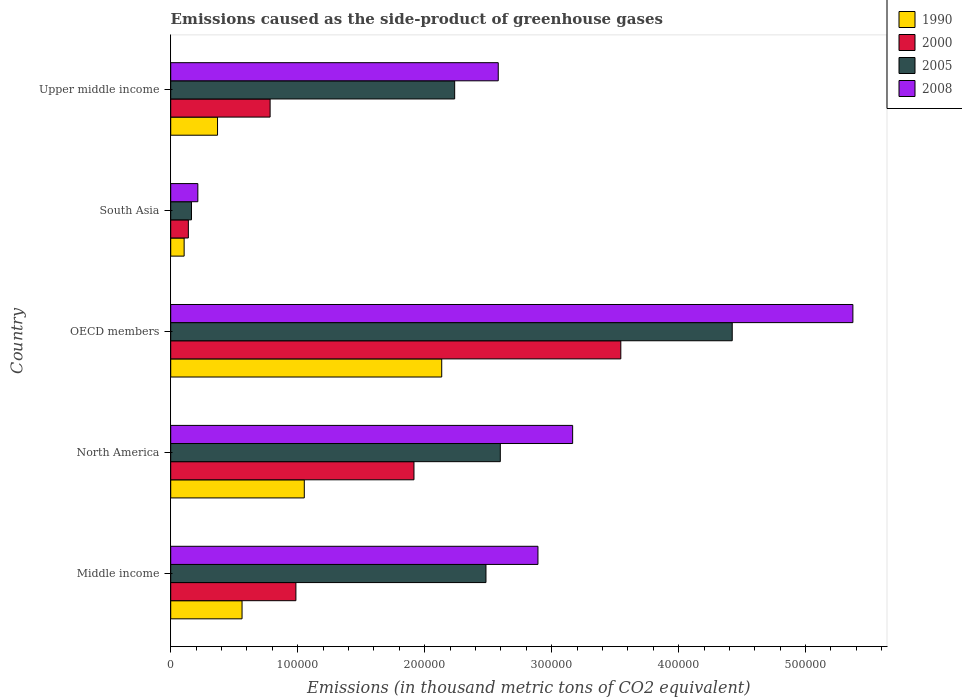How many different coloured bars are there?
Offer a very short reply. 4. How many groups of bars are there?
Offer a terse response. 5. Are the number of bars per tick equal to the number of legend labels?
Your answer should be compact. Yes. Are the number of bars on each tick of the Y-axis equal?
Provide a succinct answer. Yes. How many bars are there on the 5th tick from the top?
Keep it short and to the point. 4. How many bars are there on the 1st tick from the bottom?
Your answer should be very brief. 4. What is the label of the 4th group of bars from the top?
Give a very brief answer. North America. In how many cases, is the number of bars for a given country not equal to the number of legend labels?
Make the answer very short. 0. What is the emissions caused as the side-product of greenhouse gases in 2008 in Middle income?
Offer a terse response. 2.89e+05. Across all countries, what is the maximum emissions caused as the side-product of greenhouse gases in 2000?
Your answer should be very brief. 3.54e+05. Across all countries, what is the minimum emissions caused as the side-product of greenhouse gases in 2008?
Offer a terse response. 2.14e+04. In which country was the emissions caused as the side-product of greenhouse gases in 2000 minimum?
Ensure brevity in your answer.  South Asia. What is the total emissions caused as the side-product of greenhouse gases in 2005 in the graph?
Offer a very short reply. 1.19e+06. What is the difference between the emissions caused as the side-product of greenhouse gases in 2005 in Middle income and that in South Asia?
Your response must be concise. 2.32e+05. What is the difference between the emissions caused as the side-product of greenhouse gases in 2000 in South Asia and the emissions caused as the side-product of greenhouse gases in 2005 in Middle income?
Your answer should be compact. -2.34e+05. What is the average emissions caused as the side-product of greenhouse gases in 1990 per country?
Keep it short and to the point. 8.45e+04. What is the difference between the emissions caused as the side-product of greenhouse gases in 1990 and emissions caused as the side-product of greenhouse gases in 2005 in Middle income?
Your response must be concise. -1.92e+05. In how many countries, is the emissions caused as the side-product of greenhouse gases in 2005 greater than 120000 thousand metric tons?
Keep it short and to the point. 4. What is the ratio of the emissions caused as the side-product of greenhouse gases in 2008 in Middle income to that in South Asia?
Give a very brief answer. 13.54. Is the emissions caused as the side-product of greenhouse gases in 2005 in Middle income less than that in OECD members?
Your answer should be compact. Yes. What is the difference between the highest and the second highest emissions caused as the side-product of greenhouse gases in 2008?
Offer a very short reply. 2.21e+05. What is the difference between the highest and the lowest emissions caused as the side-product of greenhouse gases in 1990?
Your answer should be compact. 2.03e+05. In how many countries, is the emissions caused as the side-product of greenhouse gases in 2000 greater than the average emissions caused as the side-product of greenhouse gases in 2000 taken over all countries?
Ensure brevity in your answer.  2. Is it the case that in every country, the sum of the emissions caused as the side-product of greenhouse gases in 2000 and emissions caused as the side-product of greenhouse gases in 2005 is greater than the sum of emissions caused as the side-product of greenhouse gases in 2008 and emissions caused as the side-product of greenhouse gases in 1990?
Ensure brevity in your answer.  No. What does the 4th bar from the bottom in Upper middle income represents?
Your answer should be compact. 2008. Are all the bars in the graph horizontal?
Offer a terse response. Yes. How many countries are there in the graph?
Keep it short and to the point. 5. What is the difference between two consecutive major ticks on the X-axis?
Your answer should be very brief. 1.00e+05. Where does the legend appear in the graph?
Offer a terse response. Top right. How many legend labels are there?
Make the answer very short. 4. What is the title of the graph?
Keep it short and to the point. Emissions caused as the side-product of greenhouse gases. What is the label or title of the X-axis?
Make the answer very short. Emissions (in thousand metric tons of CO2 equivalent). What is the label or title of the Y-axis?
Your answer should be very brief. Country. What is the Emissions (in thousand metric tons of CO2 equivalent) in 1990 in Middle income?
Provide a short and direct response. 5.62e+04. What is the Emissions (in thousand metric tons of CO2 equivalent) in 2000 in Middle income?
Offer a terse response. 9.86e+04. What is the Emissions (in thousand metric tons of CO2 equivalent) of 2005 in Middle income?
Keep it short and to the point. 2.48e+05. What is the Emissions (in thousand metric tons of CO2 equivalent) in 2008 in Middle income?
Offer a terse response. 2.89e+05. What is the Emissions (in thousand metric tons of CO2 equivalent) of 1990 in North America?
Offer a very short reply. 1.05e+05. What is the Emissions (in thousand metric tons of CO2 equivalent) of 2000 in North America?
Give a very brief answer. 1.92e+05. What is the Emissions (in thousand metric tons of CO2 equivalent) in 2005 in North America?
Ensure brevity in your answer.  2.60e+05. What is the Emissions (in thousand metric tons of CO2 equivalent) in 2008 in North America?
Offer a terse response. 3.17e+05. What is the Emissions (in thousand metric tons of CO2 equivalent) in 1990 in OECD members?
Provide a succinct answer. 2.13e+05. What is the Emissions (in thousand metric tons of CO2 equivalent) of 2000 in OECD members?
Offer a terse response. 3.54e+05. What is the Emissions (in thousand metric tons of CO2 equivalent) of 2005 in OECD members?
Your answer should be very brief. 4.42e+05. What is the Emissions (in thousand metric tons of CO2 equivalent) in 2008 in OECD members?
Provide a short and direct response. 5.37e+05. What is the Emissions (in thousand metric tons of CO2 equivalent) in 1990 in South Asia?
Offer a very short reply. 1.06e+04. What is the Emissions (in thousand metric tons of CO2 equivalent) in 2000 in South Asia?
Ensure brevity in your answer.  1.39e+04. What is the Emissions (in thousand metric tons of CO2 equivalent) in 2005 in South Asia?
Your answer should be very brief. 1.64e+04. What is the Emissions (in thousand metric tons of CO2 equivalent) in 2008 in South Asia?
Make the answer very short. 2.14e+04. What is the Emissions (in thousand metric tons of CO2 equivalent) of 1990 in Upper middle income?
Make the answer very short. 3.69e+04. What is the Emissions (in thousand metric tons of CO2 equivalent) in 2000 in Upper middle income?
Provide a succinct answer. 7.83e+04. What is the Emissions (in thousand metric tons of CO2 equivalent) of 2005 in Upper middle income?
Offer a very short reply. 2.24e+05. What is the Emissions (in thousand metric tons of CO2 equivalent) in 2008 in Upper middle income?
Offer a terse response. 2.58e+05. Across all countries, what is the maximum Emissions (in thousand metric tons of CO2 equivalent) in 1990?
Give a very brief answer. 2.13e+05. Across all countries, what is the maximum Emissions (in thousand metric tons of CO2 equivalent) in 2000?
Your answer should be compact. 3.54e+05. Across all countries, what is the maximum Emissions (in thousand metric tons of CO2 equivalent) of 2005?
Ensure brevity in your answer.  4.42e+05. Across all countries, what is the maximum Emissions (in thousand metric tons of CO2 equivalent) of 2008?
Your answer should be compact. 5.37e+05. Across all countries, what is the minimum Emissions (in thousand metric tons of CO2 equivalent) of 1990?
Ensure brevity in your answer.  1.06e+04. Across all countries, what is the minimum Emissions (in thousand metric tons of CO2 equivalent) in 2000?
Provide a succinct answer. 1.39e+04. Across all countries, what is the minimum Emissions (in thousand metric tons of CO2 equivalent) in 2005?
Offer a very short reply. 1.64e+04. Across all countries, what is the minimum Emissions (in thousand metric tons of CO2 equivalent) in 2008?
Offer a very short reply. 2.14e+04. What is the total Emissions (in thousand metric tons of CO2 equivalent) of 1990 in the graph?
Your answer should be compact. 4.22e+05. What is the total Emissions (in thousand metric tons of CO2 equivalent) of 2000 in the graph?
Give a very brief answer. 7.37e+05. What is the total Emissions (in thousand metric tons of CO2 equivalent) in 2005 in the graph?
Give a very brief answer. 1.19e+06. What is the total Emissions (in thousand metric tons of CO2 equivalent) of 2008 in the graph?
Your answer should be very brief. 1.42e+06. What is the difference between the Emissions (in thousand metric tons of CO2 equivalent) in 1990 in Middle income and that in North America?
Keep it short and to the point. -4.90e+04. What is the difference between the Emissions (in thousand metric tons of CO2 equivalent) in 2000 in Middle income and that in North America?
Your response must be concise. -9.30e+04. What is the difference between the Emissions (in thousand metric tons of CO2 equivalent) of 2005 in Middle income and that in North America?
Give a very brief answer. -1.13e+04. What is the difference between the Emissions (in thousand metric tons of CO2 equivalent) of 2008 in Middle income and that in North America?
Keep it short and to the point. -2.73e+04. What is the difference between the Emissions (in thousand metric tons of CO2 equivalent) of 1990 in Middle income and that in OECD members?
Give a very brief answer. -1.57e+05. What is the difference between the Emissions (in thousand metric tons of CO2 equivalent) of 2000 in Middle income and that in OECD members?
Ensure brevity in your answer.  -2.56e+05. What is the difference between the Emissions (in thousand metric tons of CO2 equivalent) of 2005 in Middle income and that in OECD members?
Provide a short and direct response. -1.94e+05. What is the difference between the Emissions (in thousand metric tons of CO2 equivalent) of 2008 in Middle income and that in OECD members?
Offer a terse response. -2.48e+05. What is the difference between the Emissions (in thousand metric tons of CO2 equivalent) of 1990 in Middle income and that in South Asia?
Offer a terse response. 4.56e+04. What is the difference between the Emissions (in thousand metric tons of CO2 equivalent) of 2000 in Middle income and that in South Asia?
Give a very brief answer. 8.47e+04. What is the difference between the Emissions (in thousand metric tons of CO2 equivalent) in 2005 in Middle income and that in South Asia?
Make the answer very short. 2.32e+05. What is the difference between the Emissions (in thousand metric tons of CO2 equivalent) in 2008 in Middle income and that in South Asia?
Your response must be concise. 2.68e+05. What is the difference between the Emissions (in thousand metric tons of CO2 equivalent) of 1990 in Middle income and that in Upper middle income?
Offer a terse response. 1.93e+04. What is the difference between the Emissions (in thousand metric tons of CO2 equivalent) of 2000 in Middle income and that in Upper middle income?
Provide a short and direct response. 2.03e+04. What is the difference between the Emissions (in thousand metric tons of CO2 equivalent) of 2005 in Middle income and that in Upper middle income?
Give a very brief answer. 2.47e+04. What is the difference between the Emissions (in thousand metric tons of CO2 equivalent) in 2008 in Middle income and that in Upper middle income?
Your answer should be very brief. 3.13e+04. What is the difference between the Emissions (in thousand metric tons of CO2 equivalent) in 1990 in North America and that in OECD members?
Offer a very short reply. -1.08e+05. What is the difference between the Emissions (in thousand metric tons of CO2 equivalent) in 2000 in North America and that in OECD members?
Ensure brevity in your answer.  -1.63e+05. What is the difference between the Emissions (in thousand metric tons of CO2 equivalent) of 2005 in North America and that in OECD members?
Keep it short and to the point. -1.83e+05. What is the difference between the Emissions (in thousand metric tons of CO2 equivalent) of 2008 in North America and that in OECD members?
Give a very brief answer. -2.21e+05. What is the difference between the Emissions (in thousand metric tons of CO2 equivalent) in 1990 in North America and that in South Asia?
Your answer should be compact. 9.46e+04. What is the difference between the Emissions (in thousand metric tons of CO2 equivalent) of 2000 in North America and that in South Asia?
Your answer should be very brief. 1.78e+05. What is the difference between the Emissions (in thousand metric tons of CO2 equivalent) of 2005 in North America and that in South Asia?
Make the answer very short. 2.43e+05. What is the difference between the Emissions (in thousand metric tons of CO2 equivalent) in 2008 in North America and that in South Asia?
Offer a terse response. 2.95e+05. What is the difference between the Emissions (in thousand metric tons of CO2 equivalent) in 1990 in North America and that in Upper middle income?
Your answer should be compact. 6.83e+04. What is the difference between the Emissions (in thousand metric tons of CO2 equivalent) in 2000 in North America and that in Upper middle income?
Your answer should be very brief. 1.13e+05. What is the difference between the Emissions (in thousand metric tons of CO2 equivalent) in 2005 in North America and that in Upper middle income?
Offer a very short reply. 3.59e+04. What is the difference between the Emissions (in thousand metric tons of CO2 equivalent) of 2008 in North America and that in Upper middle income?
Your response must be concise. 5.86e+04. What is the difference between the Emissions (in thousand metric tons of CO2 equivalent) of 1990 in OECD members and that in South Asia?
Your response must be concise. 2.03e+05. What is the difference between the Emissions (in thousand metric tons of CO2 equivalent) in 2000 in OECD members and that in South Asia?
Make the answer very short. 3.41e+05. What is the difference between the Emissions (in thousand metric tons of CO2 equivalent) of 2005 in OECD members and that in South Asia?
Provide a short and direct response. 4.26e+05. What is the difference between the Emissions (in thousand metric tons of CO2 equivalent) in 2008 in OECD members and that in South Asia?
Offer a very short reply. 5.16e+05. What is the difference between the Emissions (in thousand metric tons of CO2 equivalent) of 1990 in OECD members and that in Upper middle income?
Make the answer very short. 1.77e+05. What is the difference between the Emissions (in thousand metric tons of CO2 equivalent) of 2000 in OECD members and that in Upper middle income?
Keep it short and to the point. 2.76e+05. What is the difference between the Emissions (in thousand metric tons of CO2 equivalent) in 2005 in OECD members and that in Upper middle income?
Ensure brevity in your answer.  2.19e+05. What is the difference between the Emissions (in thousand metric tons of CO2 equivalent) in 2008 in OECD members and that in Upper middle income?
Your answer should be compact. 2.79e+05. What is the difference between the Emissions (in thousand metric tons of CO2 equivalent) of 1990 in South Asia and that in Upper middle income?
Keep it short and to the point. -2.63e+04. What is the difference between the Emissions (in thousand metric tons of CO2 equivalent) of 2000 in South Asia and that in Upper middle income?
Keep it short and to the point. -6.44e+04. What is the difference between the Emissions (in thousand metric tons of CO2 equivalent) in 2005 in South Asia and that in Upper middle income?
Give a very brief answer. -2.07e+05. What is the difference between the Emissions (in thousand metric tons of CO2 equivalent) in 2008 in South Asia and that in Upper middle income?
Your response must be concise. -2.37e+05. What is the difference between the Emissions (in thousand metric tons of CO2 equivalent) in 1990 in Middle income and the Emissions (in thousand metric tons of CO2 equivalent) in 2000 in North America?
Your response must be concise. -1.35e+05. What is the difference between the Emissions (in thousand metric tons of CO2 equivalent) of 1990 in Middle income and the Emissions (in thousand metric tons of CO2 equivalent) of 2005 in North America?
Offer a terse response. -2.03e+05. What is the difference between the Emissions (in thousand metric tons of CO2 equivalent) of 1990 in Middle income and the Emissions (in thousand metric tons of CO2 equivalent) of 2008 in North America?
Your answer should be compact. -2.60e+05. What is the difference between the Emissions (in thousand metric tons of CO2 equivalent) in 2000 in Middle income and the Emissions (in thousand metric tons of CO2 equivalent) in 2005 in North America?
Offer a very short reply. -1.61e+05. What is the difference between the Emissions (in thousand metric tons of CO2 equivalent) in 2000 in Middle income and the Emissions (in thousand metric tons of CO2 equivalent) in 2008 in North America?
Your answer should be compact. -2.18e+05. What is the difference between the Emissions (in thousand metric tons of CO2 equivalent) of 2005 in Middle income and the Emissions (in thousand metric tons of CO2 equivalent) of 2008 in North America?
Ensure brevity in your answer.  -6.83e+04. What is the difference between the Emissions (in thousand metric tons of CO2 equivalent) in 1990 in Middle income and the Emissions (in thousand metric tons of CO2 equivalent) in 2000 in OECD members?
Your response must be concise. -2.98e+05. What is the difference between the Emissions (in thousand metric tons of CO2 equivalent) of 1990 in Middle income and the Emissions (in thousand metric tons of CO2 equivalent) of 2005 in OECD members?
Ensure brevity in your answer.  -3.86e+05. What is the difference between the Emissions (in thousand metric tons of CO2 equivalent) in 1990 in Middle income and the Emissions (in thousand metric tons of CO2 equivalent) in 2008 in OECD members?
Your answer should be very brief. -4.81e+05. What is the difference between the Emissions (in thousand metric tons of CO2 equivalent) of 2000 in Middle income and the Emissions (in thousand metric tons of CO2 equivalent) of 2005 in OECD members?
Provide a succinct answer. -3.44e+05. What is the difference between the Emissions (in thousand metric tons of CO2 equivalent) in 2000 in Middle income and the Emissions (in thousand metric tons of CO2 equivalent) in 2008 in OECD members?
Your response must be concise. -4.39e+05. What is the difference between the Emissions (in thousand metric tons of CO2 equivalent) of 2005 in Middle income and the Emissions (in thousand metric tons of CO2 equivalent) of 2008 in OECD members?
Provide a short and direct response. -2.89e+05. What is the difference between the Emissions (in thousand metric tons of CO2 equivalent) in 1990 in Middle income and the Emissions (in thousand metric tons of CO2 equivalent) in 2000 in South Asia?
Your answer should be very brief. 4.23e+04. What is the difference between the Emissions (in thousand metric tons of CO2 equivalent) of 1990 in Middle income and the Emissions (in thousand metric tons of CO2 equivalent) of 2005 in South Asia?
Your answer should be very brief. 3.98e+04. What is the difference between the Emissions (in thousand metric tons of CO2 equivalent) in 1990 in Middle income and the Emissions (in thousand metric tons of CO2 equivalent) in 2008 in South Asia?
Your answer should be compact. 3.48e+04. What is the difference between the Emissions (in thousand metric tons of CO2 equivalent) in 2000 in Middle income and the Emissions (in thousand metric tons of CO2 equivalent) in 2005 in South Asia?
Make the answer very short. 8.22e+04. What is the difference between the Emissions (in thousand metric tons of CO2 equivalent) of 2000 in Middle income and the Emissions (in thousand metric tons of CO2 equivalent) of 2008 in South Asia?
Offer a very short reply. 7.72e+04. What is the difference between the Emissions (in thousand metric tons of CO2 equivalent) in 2005 in Middle income and the Emissions (in thousand metric tons of CO2 equivalent) in 2008 in South Asia?
Keep it short and to the point. 2.27e+05. What is the difference between the Emissions (in thousand metric tons of CO2 equivalent) of 1990 in Middle income and the Emissions (in thousand metric tons of CO2 equivalent) of 2000 in Upper middle income?
Offer a terse response. -2.21e+04. What is the difference between the Emissions (in thousand metric tons of CO2 equivalent) of 1990 in Middle income and the Emissions (in thousand metric tons of CO2 equivalent) of 2005 in Upper middle income?
Offer a terse response. -1.67e+05. What is the difference between the Emissions (in thousand metric tons of CO2 equivalent) in 1990 in Middle income and the Emissions (in thousand metric tons of CO2 equivalent) in 2008 in Upper middle income?
Provide a short and direct response. -2.02e+05. What is the difference between the Emissions (in thousand metric tons of CO2 equivalent) in 2000 in Middle income and the Emissions (in thousand metric tons of CO2 equivalent) in 2005 in Upper middle income?
Keep it short and to the point. -1.25e+05. What is the difference between the Emissions (in thousand metric tons of CO2 equivalent) in 2000 in Middle income and the Emissions (in thousand metric tons of CO2 equivalent) in 2008 in Upper middle income?
Your answer should be compact. -1.59e+05. What is the difference between the Emissions (in thousand metric tons of CO2 equivalent) in 2005 in Middle income and the Emissions (in thousand metric tons of CO2 equivalent) in 2008 in Upper middle income?
Give a very brief answer. -9667. What is the difference between the Emissions (in thousand metric tons of CO2 equivalent) of 1990 in North America and the Emissions (in thousand metric tons of CO2 equivalent) of 2000 in OECD members?
Offer a very short reply. -2.49e+05. What is the difference between the Emissions (in thousand metric tons of CO2 equivalent) of 1990 in North America and the Emissions (in thousand metric tons of CO2 equivalent) of 2005 in OECD members?
Make the answer very short. -3.37e+05. What is the difference between the Emissions (in thousand metric tons of CO2 equivalent) of 1990 in North America and the Emissions (in thousand metric tons of CO2 equivalent) of 2008 in OECD members?
Keep it short and to the point. -4.32e+05. What is the difference between the Emissions (in thousand metric tons of CO2 equivalent) in 2000 in North America and the Emissions (in thousand metric tons of CO2 equivalent) in 2005 in OECD members?
Your answer should be very brief. -2.51e+05. What is the difference between the Emissions (in thousand metric tons of CO2 equivalent) of 2000 in North America and the Emissions (in thousand metric tons of CO2 equivalent) of 2008 in OECD members?
Offer a very short reply. -3.46e+05. What is the difference between the Emissions (in thousand metric tons of CO2 equivalent) in 2005 in North America and the Emissions (in thousand metric tons of CO2 equivalent) in 2008 in OECD members?
Your answer should be compact. -2.78e+05. What is the difference between the Emissions (in thousand metric tons of CO2 equivalent) in 1990 in North America and the Emissions (in thousand metric tons of CO2 equivalent) in 2000 in South Asia?
Provide a succinct answer. 9.13e+04. What is the difference between the Emissions (in thousand metric tons of CO2 equivalent) of 1990 in North America and the Emissions (in thousand metric tons of CO2 equivalent) of 2005 in South Asia?
Give a very brief answer. 8.88e+04. What is the difference between the Emissions (in thousand metric tons of CO2 equivalent) in 1990 in North America and the Emissions (in thousand metric tons of CO2 equivalent) in 2008 in South Asia?
Offer a very short reply. 8.38e+04. What is the difference between the Emissions (in thousand metric tons of CO2 equivalent) in 2000 in North America and the Emissions (in thousand metric tons of CO2 equivalent) in 2005 in South Asia?
Provide a succinct answer. 1.75e+05. What is the difference between the Emissions (in thousand metric tons of CO2 equivalent) in 2000 in North America and the Emissions (in thousand metric tons of CO2 equivalent) in 2008 in South Asia?
Offer a very short reply. 1.70e+05. What is the difference between the Emissions (in thousand metric tons of CO2 equivalent) in 2005 in North America and the Emissions (in thousand metric tons of CO2 equivalent) in 2008 in South Asia?
Give a very brief answer. 2.38e+05. What is the difference between the Emissions (in thousand metric tons of CO2 equivalent) in 1990 in North America and the Emissions (in thousand metric tons of CO2 equivalent) in 2000 in Upper middle income?
Ensure brevity in your answer.  2.69e+04. What is the difference between the Emissions (in thousand metric tons of CO2 equivalent) of 1990 in North America and the Emissions (in thousand metric tons of CO2 equivalent) of 2005 in Upper middle income?
Your response must be concise. -1.18e+05. What is the difference between the Emissions (in thousand metric tons of CO2 equivalent) in 1990 in North America and the Emissions (in thousand metric tons of CO2 equivalent) in 2008 in Upper middle income?
Provide a succinct answer. -1.53e+05. What is the difference between the Emissions (in thousand metric tons of CO2 equivalent) of 2000 in North America and the Emissions (in thousand metric tons of CO2 equivalent) of 2005 in Upper middle income?
Your response must be concise. -3.21e+04. What is the difference between the Emissions (in thousand metric tons of CO2 equivalent) of 2000 in North America and the Emissions (in thousand metric tons of CO2 equivalent) of 2008 in Upper middle income?
Offer a terse response. -6.64e+04. What is the difference between the Emissions (in thousand metric tons of CO2 equivalent) in 2005 in North America and the Emissions (in thousand metric tons of CO2 equivalent) in 2008 in Upper middle income?
Offer a terse response. 1628.2. What is the difference between the Emissions (in thousand metric tons of CO2 equivalent) in 1990 in OECD members and the Emissions (in thousand metric tons of CO2 equivalent) in 2000 in South Asia?
Your answer should be very brief. 2.00e+05. What is the difference between the Emissions (in thousand metric tons of CO2 equivalent) of 1990 in OECD members and the Emissions (in thousand metric tons of CO2 equivalent) of 2005 in South Asia?
Make the answer very short. 1.97e+05. What is the difference between the Emissions (in thousand metric tons of CO2 equivalent) in 1990 in OECD members and the Emissions (in thousand metric tons of CO2 equivalent) in 2008 in South Asia?
Keep it short and to the point. 1.92e+05. What is the difference between the Emissions (in thousand metric tons of CO2 equivalent) in 2000 in OECD members and the Emissions (in thousand metric tons of CO2 equivalent) in 2005 in South Asia?
Provide a succinct answer. 3.38e+05. What is the difference between the Emissions (in thousand metric tons of CO2 equivalent) in 2000 in OECD members and the Emissions (in thousand metric tons of CO2 equivalent) in 2008 in South Asia?
Ensure brevity in your answer.  3.33e+05. What is the difference between the Emissions (in thousand metric tons of CO2 equivalent) in 2005 in OECD members and the Emissions (in thousand metric tons of CO2 equivalent) in 2008 in South Asia?
Make the answer very short. 4.21e+05. What is the difference between the Emissions (in thousand metric tons of CO2 equivalent) in 1990 in OECD members and the Emissions (in thousand metric tons of CO2 equivalent) in 2000 in Upper middle income?
Provide a succinct answer. 1.35e+05. What is the difference between the Emissions (in thousand metric tons of CO2 equivalent) in 1990 in OECD members and the Emissions (in thousand metric tons of CO2 equivalent) in 2005 in Upper middle income?
Provide a short and direct response. -1.02e+04. What is the difference between the Emissions (in thousand metric tons of CO2 equivalent) of 1990 in OECD members and the Emissions (in thousand metric tons of CO2 equivalent) of 2008 in Upper middle income?
Your answer should be very brief. -4.45e+04. What is the difference between the Emissions (in thousand metric tons of CO2 equivalent) in 2000 in OECD members and the Emissions (in thousand metric tons of CO2 equivalent) in 2005 in Upper middle income?
Give a very brief answer. 1.31e+05. What is the difference between the Emissions (in thousand metric tons of CO2 equivalent) in 2000 in OECD members and the Emissions (in thousand metric tons of CO2 equivalent) in 2008 in Upper middle income?
Offer a very short reply. 9.65e+04. What is the difference between the Emissions (in thousand metric tons of CO2 equivalent) in 2005 in OECD members and the Emissions (in thousand metric tons of CO2 equivalent) in 2008 in Upper middle income?
Your answer should be compact. 1.84e+05. What is the difference between the Emissions (in thousand metric tons of CO2 equivalent) of 1990 in South Asia and the Emissions (in thousand metric tons of CO2 equivalent) of 2000 in Upper middle income?
Make the answer very short. -6.77e+04. What is the difference between the Emissions (in thousand metric tons of CO2 equivalent) in 1990 in South Asia and the Emissions (in thousand metric tons of CO2 equivalent) in 2005 in Upper middle income?
Make the answer very short. -2.13e+05. What is the difference between the Emissions (in thousand metric tons of CO2 equivalent) of 1990 in South Asia and the Emissions (in thousand metric tons of CO2 equivalent) of 2008 in Upper middle income?
Offer a very short reply. -2.47e+05. What is the difference between the Emissions (in thousand metric tons of CO2 equivalent) in 2000 in South Asia and the Emissions (in thousand metric tons of CO2 equivalent) in 2005 in Upper middle income?
Your answer should be compact. -2.10e+05. What is the difference between the Emissions (in thousand metric tons of CO2 equivalent) in 2000 in South Asia and the Emissions (in thousand metric tons of CO2 equivalent) in 2008 in Upper middle income?
Keep it short and to the point. -2.44e+05. What is the difference between the Emissions (in thousand metric tons of CO2 equivalent) in 2005 in South Asia and the Emissions (in thousand metric tons of CO2 equivalent) in 2008 in Upper middle income?
Make the answer very short. -2.42e+05. What is the average Emissions (in thousand metric tons of CO2 equivalent) of 1990 per country?
Make the answer very short. 8.45e+04. What is the average Emissions (in thousand metric tons of CO2 equivalent) of 2000 per country?
Your response must be concise. 1.47e+05. What is the average Emissions (in thousand metric tons of CO2 equivalent) of 2005 per country?
Provide a short and direct response. 2.38e+05. What is the average Emissions (in thousand metric tons of CO2 equivalent) in 2008 per country?
Ensure brevity in your answer.  2.84e+05. What is the difference between the Emissions (in thousand metric tons of CO2 equivalent) of 1990 and Emissions (in thousand metric tons of CO2 equivalent) of 2000 in Middle income?
Your answer should be compact. -4.24e+04. What is the difference between the Emissions (in thousand metric tons of CO2 equivalent) in 1990 and Emissions (in thousand metric tons of CO2 equivalent) in 2005 in Middle income?
Your answer should be compact. -1.92e+05. What is the difference between the Emissions (in thousand metric tons of CO2 equivalent) in 1990 and Emissions (in thousand metric tons of CO2 equivalent) in 2008 in Middle income?
Provide a succinct answer. -2.33e+05. What is the difference between the Emissions (in thousand metric tons of CO2 equivalent) in 2000 and Emissions (in thousand metric tons of CO2 equivalent) in 2005 in Middle income?
Your answer should be compact. -1.50e+05. What is the difference between the Emissions (in thousand metric tons of CO2 equivalent) in 2000 and Emissions (in thousand metric tons of CO2 equivalent) in 2008 in Middle income?
Provide a succinct answer. -1.91e+05. What is the difference between the Emissions (in thousand metric tons of CO2 equivalent) in 2005 and Emissions (in thousand metric tons of CO2 equivalent) in 2008 in Middle income?
Your answer should be very brief. -4.09e+04. What is the difference between the Emissions (in thousand metric tons of CO2 equivalent) in 1990 and Emissions (in thousand metric tons of CO2 equivalent) in 2000 in North America?
Keep it short and to the point. -8.64e+04. What is the difference between the Emissions (in thousand metric tons of CO2 equivalent) in 1990 and Emissions (in thousand metric tons of CO2 equivalent) in 2005 in North America?
Offer a very short reply. -1.54e+05. What is the difference between the Emissions (in thousand metric tons of CO2 equivalent) in 1990 and Emissions (in thousand metric tons of CO2 equivalent) in 2008 in North America?
Give a very brief answer. -2.11e+05. What is the difference between the Emissions (in thousand metric tons of CO2 equivalent) of 2000 and Emissions (in thousand metric tons of CO2 equivalent) of 2005 in North America?
Your answer should be very brief. -6.80e+04. What is the difference between the Emissions (in thousand metric tons of CO2 equivalent) of 2000 and Emissions (in thousand metric tons of CO2 equivalent) of 2008 in North America?
Your response must be concise. -1.25e+05. What is the difference between the Emissions (in thousand metric tons of CO2 equivalent) of 2005 and Emissions (in thousand metric tons of CO2 equivalent) of 2008 in North America?
Provide a short and direct response. -5.70e+04. What is the difference between the Emissions (in thousand metric tons of CO2 equivalent) in 1990 and Emissions (in thousand metric tons of CO2 equivalent) in 2000 in OECD members?
Ensure brevity in your answer.  -1.41e+05. What is the difference between the Emissions (in thousand metric tons of CO2 equivalent) in 1990 and Emissions (in thousand metric tons of CO2 equivalent) in 2005 in OECD members?
Provide a succinct answer. -2.29e+05. What is the difference between the Emissions (in thousand metric tons of CO2 equivalent) in 1990 and Emissions (in thousand metric tons of CO2 equivalent) in 2008 in OECD members?
Provide a short and direct response. -3.24e+05. What is the difference between the Emissions (in thousand metric tons of CO2 equivalent) of 2000 and Emissions (in thousand metric tons of CO2 equivalent) of 2005 in OECD members?
Give a very brief answer. -8.78e+04. What is the difference between the Emissions (in thousand metric tons of CO2 equivalent) of 2000 and Emissions (in thousand metric tons of CO2 equivalent) of 2008 in OECD members?
Offer a very short reply. -1.83e+05. What is the difference between the Emissions (in thousand metric tons of CO2 equivalent) of 2005 and Emissions (in thousand metric tons of CO2 equivalent) of 2008 in OECD members?
Provide a short and direct response. -9.50e+04. What is the difference between the Emissions (in thousand metric tons of CO2 equivalent) of 1990 and Emissions (in thousand metric tons of CO2 equivalent) of 2000 in South Asia?
Keep it short and to the point. -3325.3. What is the difference between the Emissions (in thousand metric tons of CO2 equivalent) in 1990 and Emissions (in thousand metric tons of CO2 equivalent) in 2005 in South Asia?
Provide a succinct answer. -5786.5. What is the difference between the Emissions (in thousand metric tons of CO2 equivalent) of 1990 and Emissions (in thousand metric tons of CO2 equivalent) of 2008 in South Asia?
Keep it short and to the point. -1.08e+04. What is the difference between the Emissions (in thousand metric tons of CO2 equivalent) of 2000 and Emissions (in thousand metric tons of CO2 equivalent) of 2005 in South Asia?
Offer a terse response. -2461.2. What is the difference between the Emissions (in thousand metric tons of CO2 equivalent) in 2000 and Emissions (in thousand metric tons of CO2 equivalent) in 2008 in South Asia?
Make the answer very short. -7460.6. What is the difference between the Emissions (in thousand metric tons of CO2 equivalent) in 2005 and Emissions (in thousand metric tons of CO2 equivalent) in 2008 in South Asia?
Your answer should be compact. -4999.4. What is the difference between the Emissions (in thousand metric tons of CO2 equivalent) of 1990 and Emissions (in thousand metric tons of CO2 equivalent) of 2000 in Upper middle income?
Make the answer very short. -4.14e+04. What is the difference between the Emissions (in thousand metric tons of CO2 equivalent) of 1990 and Emissions (in thousand metric tons of CO2 equivalent) of 2005 in Upper middle income?
Your answer should be very brief. -1.87e+05. What is the difference between the Emissions (in thousand metric tons of CO2 equivalent) of 1990 and Emissions (in thousand metric tons of CO2 equivalent) of 2008 in Upper middle income?
Your response must be concise. -2.21e+05. What is the difference between the Emissions (in thousand metric tons of CO2 equivalent) of 2000 and Emissions (in thousand metric tons of CO2 equivalent) of 2005 in Upper middle income?
Keep it short and to the point. -1.45e+05. What is the difference between the Emissions (in thousand metric tons of CO2 equivalent) in 2000 and Emissions (in thousand metric tons of CO2 equivalent) in 2008 in Upper middle income?
Make the answer very short. -1.80e+05. What is the difference between the Emissions (in thousand metric tons of CO2 equivalent) in 2005 and Emissions (in thousand metric tons of CO2 equivalent) in 2008 in Upper middle income?
Your answer should be compact. -3.43e+04. What is the ratio of the Emissions (in thousand metric tons of CO2 equivalent) in 1990 in Middle income to that in North America?
Your response must be concise. 0.53. What is the ratio of the Emissions (in thousand metric tons of CO2 equivalent) of 2000 in Middle income to that in North America?
Offer a very short reply. 0.51. What is the ratio of the Emissions (in thousand metric tons of CO2 equivalent) of 2005 in Middle income to that in North America?
Your answer should be very brief. 0.96. What is the ratio of the Emissions (in thousand metric tons of CO2 equivalent) in 2008 in Middle income to that in North America?
Ensure brevity in your answer.  0.91. What is the ratio of the Emissions (in thousand metric tons of CO2 equivalent) in 1990 in Middle income to that in OECD members?
Keep it short and to the point. 0.26. What is the ratio of the Emissions (in thousand metric tons of CO2 equivalent) in 2000 in Middle income to that in OECD members?
Offer a very short reply. 0.28. What is the ratio of the Emissions (in thousand metric tons of CO2 equivalent) of 2005 in Middle income to that in OECD members?
Provide a short and direct response. 0.56. What is the ratio of the Emissions (in thousand metric tons of CO2 equivalent) in 2008 in Middle income to that in OECD members?
Your answer should be very brief. 0.54. What is the ratio of the Emissions (in thousand metric tons of CO2 equivalent) of 1990 in Middle income to that in South Asia?
Offer a very short reply. 5.31. What is the ratio of the Emissions (in thousand metric tons of CO2 equivalent) of 2000 in Middle income to that in South Asia?
Ensure brevity in your answer.  7.09. What is the ratio of the Emissions (in thousand metric tons of CO2 equivalent) in 2005 in Middle income to that in South Asia?
Keep it short and to the point. 15.18. What is the ratio of the Emissions (in thousand metric tons of CO2 equivalent) in 2008 in Middle income to that in South Asia?
Give a very brief answer. 13.54. What is the ratio of the Emissions (in thousand metric tons of CO2 equivalent) of 1990 in Middle income to that in Upper middle income?
Provide a succinct answer. 1.52. What is the ratio of the Emissions (in thousand metric tons of CO2 equivalent) in 2000 in Middle income to that in Upper middle income?
Make the answer very short. 1.26. What is the ratio of the Emissions (in thousand metric tons of CO2 equivalent) in 2005 in Middle income to that in Upper middle income?
Keep it short and to the point. 1.11. What is the ratio of the Emissions (in thousand metric tons of CO2 equivalent) in 2008 in Middle income to that in Upper middle income?
Make the answer very short. 1.12. What is the ratio of the Emissions (in thousand metric tons of CO2 equivalent) of 1990 in North America to that in OECD members?
Offer a terse response. 0.49. What is the ratio of the Emissions (in thousand metric tons of CO2 equivalent) in 2000 in North America to that in OECD members?
Your answer should be very brief. 0.54. What is the ratio of the Emissions (in thousand metric tons of CO2 equivalent) of 2005 in North America to that in OECD members?
Offer a very short reply. 0.59. What is the ratio of the Emissions (in thousand metric tons of CO2 equivalent) in 2008 in North America to that in OECD members?
Your response must be concise. 0.59. What is the ratio of the Emissions (in thousand metric tons of CO2 equivalent) in 1990 in North America to that in South Asia?
Give a very brief answer. 9.95. What is the ratio of the Emissions (in thousand metric tons of CO2 equivalent) of 2000 in North America to that in South Asia?
Make the answer very short. 13.79. What is the ratio of the Emissions (in thousand metric tons of CO2 equivalent) of 2005 in North America to that in South Asia?
Your response must be concise. 15.87. What is the ratio of the Emissions (in thousand metric tons of CO2 equivalent) in 2008 in North America to that in South Asia?
Offer a terse response. 14.82. What is the ratio of the Emissions (in thousand metric tons of CO2 equivalent) in 1990 in North America to that in Upper middle income?
Offer a very short reply. 2.85. What is the ratio of the Emissions (in thousand metric tons of CO2 equivalent) in 2000 in North America to that in Upper middle income?
Keep it short and to the point. 2.45. What is the ratio of the Emissions (in thousand metric tons of CO2 equivalent) of 2005 in North America to that in Upper middle income?
Your response must be concise. 1.16. What is the ratio of the Emissions (in thousand metric tons of CO2 equivalent) in 2008 in North America to that in Upper middle income?
Keep it short and to the point. 1.23. What is the ratio of the Emissions (in thousand metric tons of CO2 equivalent) of 1990 in OECD members to that in South Asia?
Offer a very short reply. 20.19. What is the ratio of the Emissions (in thousand metric tons of CO2 equivalent) of 2000 in OECD members to that in South Asia?
Ensure brevity in your answer.  25.51. What is the ratio of the Emissions (in thousand metric tons of CO2 equivalent) of 2005 in OECD members to that in South Asia?
Ensure brevity in your answer.  27.03. What is the ratio of the Emissions (in thousand metric tons of CO2 equivalent) of 2008 in OECD members to that in South Asia?
Keep it short and to the point. 25.15. What is the ratio of the Emissions (in thousand metric tons of CO2 equivalent) in 1990 in OECD members to that in Upper middle income?
Make the answer very short. 5.79. What is the ratio of the Emissions (in thousand metric tons of CO2 equivalent) of 2000 in OECD members to that in Upper middle income?
Give a very brief answer. 4.53. What is the ratio of the Emissions (in thousand metric tons of CO2 equivalent) in 2005 in OECD members to that in Upper middle income?
Offer a very short reply. 1.98. What is the ratio of the Emissions (in thousand metric tons of CO2 equivalent) of 2008 in OECD members to that in Upper middle income?
Provide a short and direct response. 2.08. What is the ratio of the Emissions (in thousand metric tons of CO2 equivalent) of 1990 in South Asia to that in Upper middle income?
Provide a succinct answer. 0.29. What is the ratio of the Emissions (in thousand metric tons of CO2 equivalent) of 2000 in South Asia to that in Upper middle income?
Provide a succinct answer. 0.18. What is the ratio of the Emissions (in thousand metric tons of CO2 equivalent) of 2005 in South Asia to that in Upper middle income?
Ensure brevity in your answer.  0.07. What is the ratio of the Emissions (in thousand metric tons of CO2 equivalent) of 2008 in South Asia to that in Upper middle income?
Keep it short and to the point. 0.08. What is the difference between the highest and the second highest Emissions (in thousand metric tons of CO2 equivalent) of 1990?
Offer a terse response. 1.08e+05. What is the difference between the highest and the second highest Emissions (in thousand metric tons of CO2 equivalent) of 2000?
Make the answer very short. 1.63e+05. What is the difference between the highest and the second highest Emissions (in thousand metric tons of CO2 equivalent) of 2005?
Offer a very short reply. 1.83e+05. What is the difference between the highest and the second highest Emissions (in thousand metric tons of CO2 equivalent) in 2008?
Provide a short and direct response. 2.21e+05. What is the difference between the highest and the lowest Emissions (in thousand metric tons of CO2 equivalent) in 1990?
Provide a succinct answer. 2.03e+05. What is the difference between the highest and the lowest Emissions (in thousand metric tons of CO2 equivalent) in 2000?
Provide a short and direct response. 3.41e+05. What is the difference between the highest and the lowest Emissions (in thousand metric tons of CO2 equivalent) of 2005?
Ensure brevity in your answer.  4.26e+05. What is the difference between the highest and the lowest Emissions (in thousand metric tons of CO2 equivalent) in 2008?
Provide a succinct answer. 5.16e+05. 